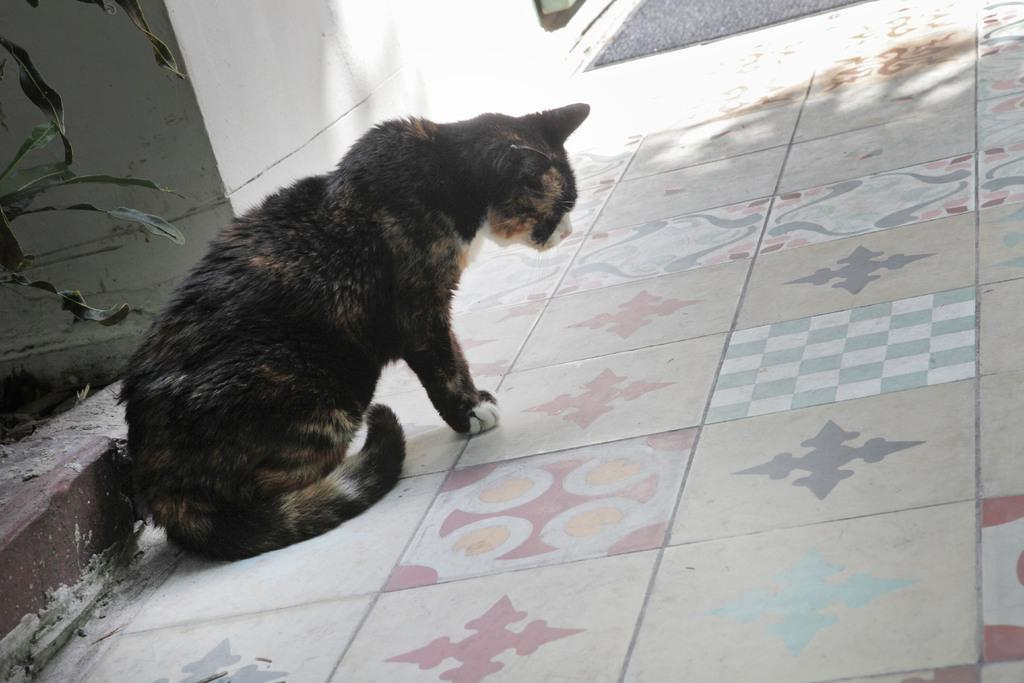What type of animal is in the picture? There is a cat in the picture. What color is the cat? The cat is black in color. Where is the cat located in the picture? The cat is on the floor. What can be seen in the background of the picture? There is a wall and leaves of a plant visible in the background. What type of food is the cat eating in the picture? There is no food present in the image, so it cannot be determined what the cat might be eating. 